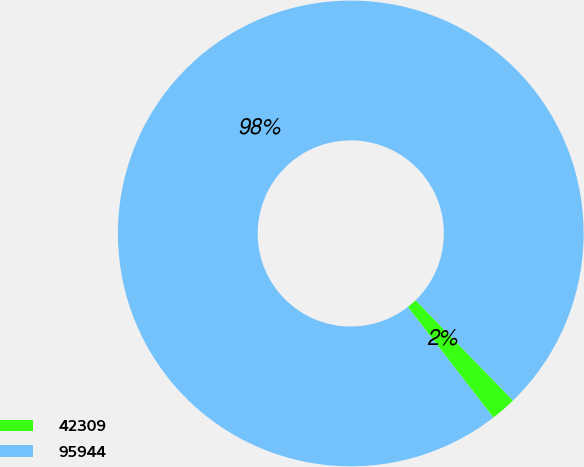<chart> <loc_0><loc_0><loc_500><loc_500><pie_chart><fcel>42309<fcel>95944<nl><fcel>1.78%<fcel>98.22%<nl></chart> 